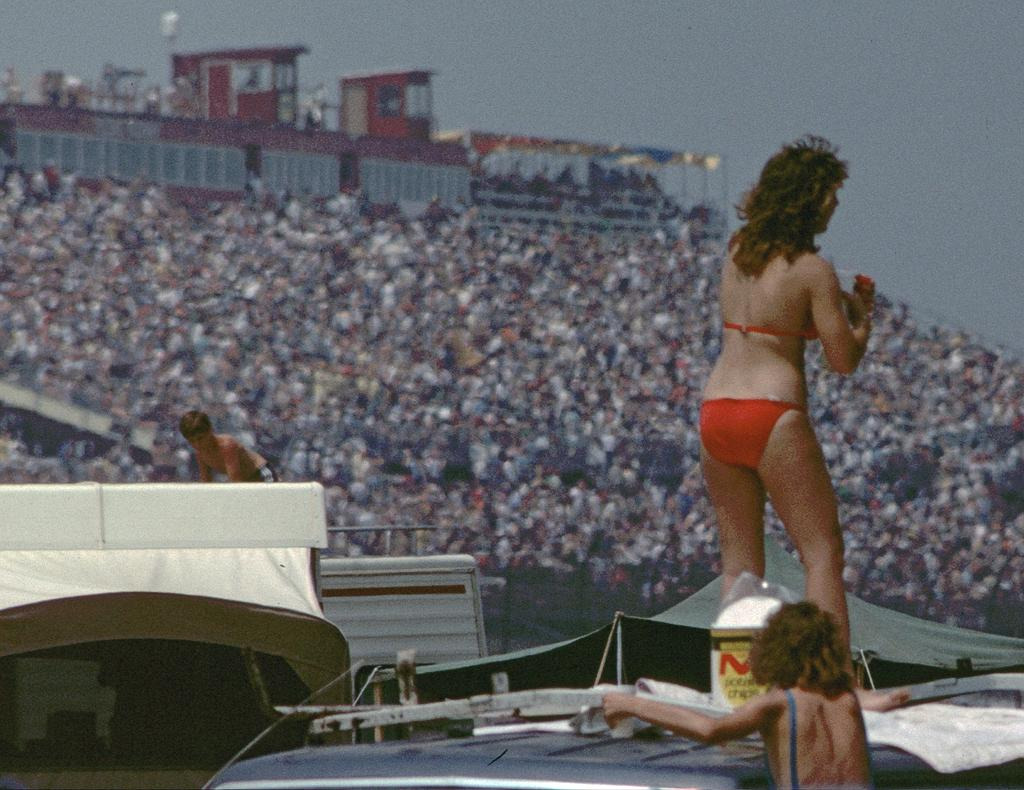What is the main subject of the image? The main subject of the image is people on a vehicle. Can you describe the background of the image? The background of the image is blurred. How many chickens are sitting on the seat in the image? There are no chickens present in the image. What type of pest can be seen crawling on the vehicle in the image? There is no pest visible in the image. 